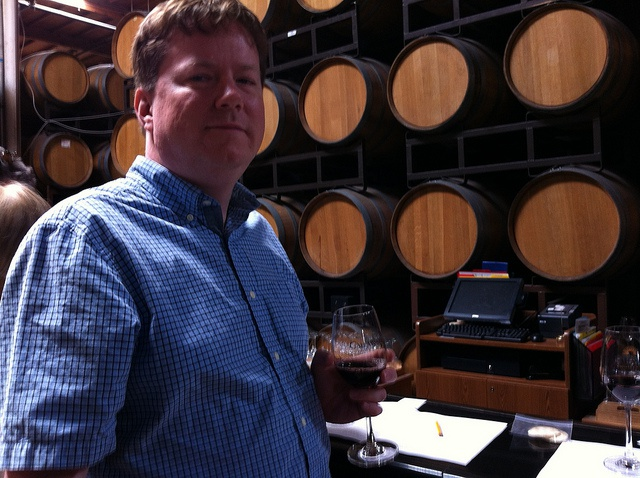Describe the objects in this image and their specific colors. I can see people in gray, black, navy, and maroon tones, wine glass in gray, black, maroon, and darkgray tones, wine glass in gray, black, lavender, and maroon tones, tv in gray, black, navy, blue, and darkblue tones, and keyboard in gray, black, and maroon tones in this image. 